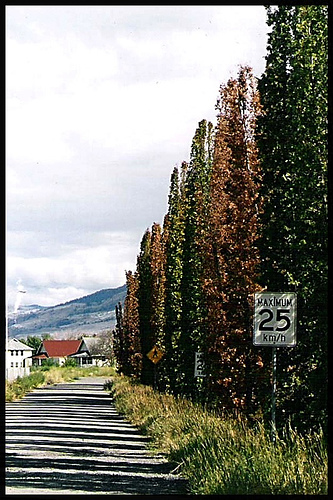Please transcribe the text information in this image. MAXIMUM 25 km/h 